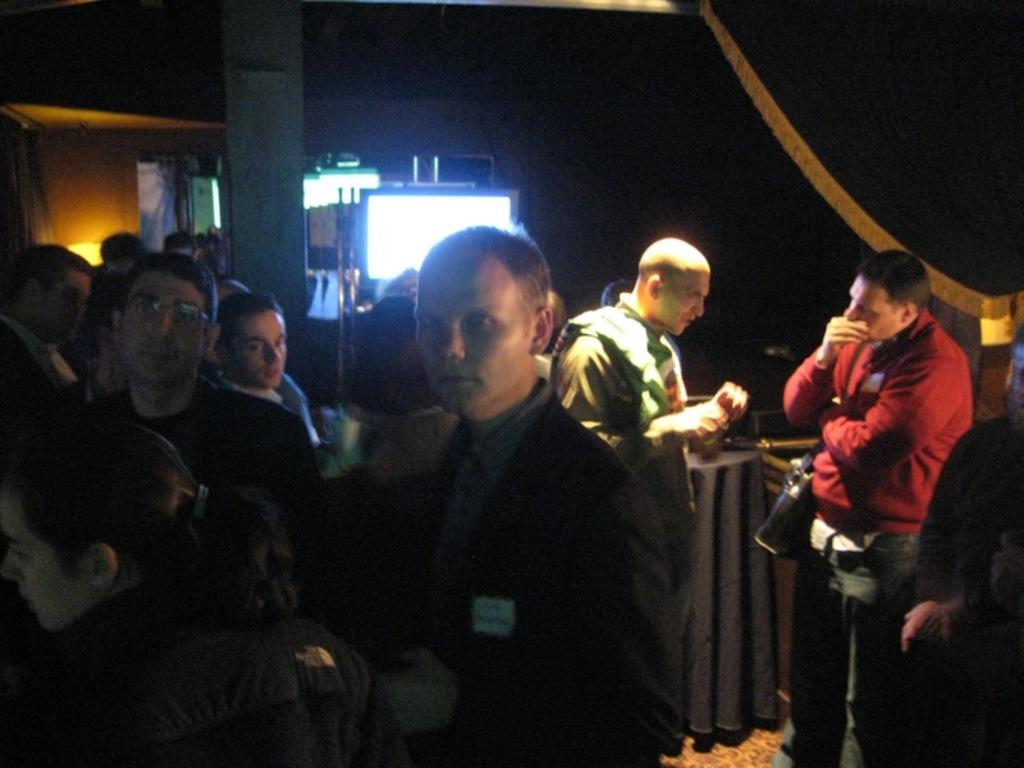How many people are in the image? There is a group of people standing in the image. What can be seen in the background of the image? There appears to be a screen and possibly a door in the background of the image. What is located in the foreground of the image? There is a table in the foreground of the image. What is at the bottom of the image? There is a mat at the bottom of the image. How many oranges are on the table in the image? There is no mention of oranges in the image; the table is not described as having any oranges on it. 